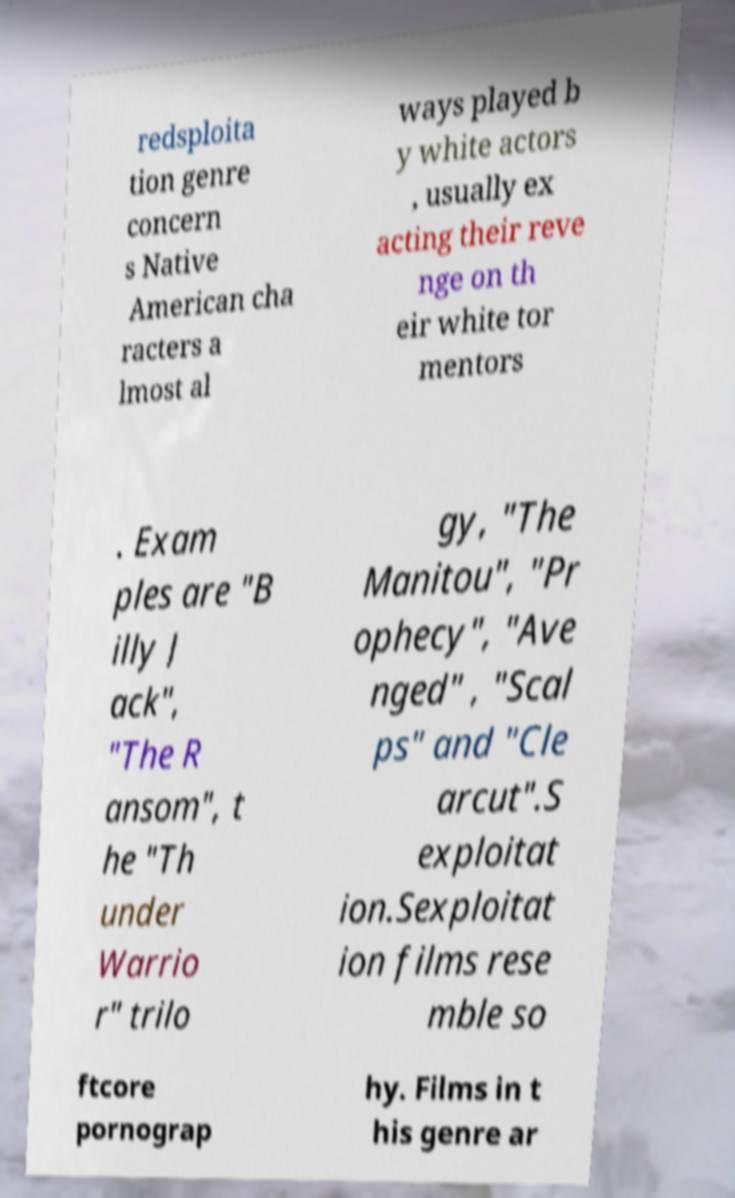I need the written content from this picture converted into text. Can you do that? redsploita tion genre concern s Native American cha racters a lmost al ways played b y white actors , usually ex acting their reve nge on th eir white tor mentors . Exam ples are "B illy J ack", "The R ansom", t he "Th under Warrio r" trilo gy, "The Manitou", "Pr ophecy", "Ave nged" , "Scal ps" and "Cle arcut".S exploitat ion.Sexploitat ion films rese mble so ftcore pornograp hy. Films in t his genre ar 